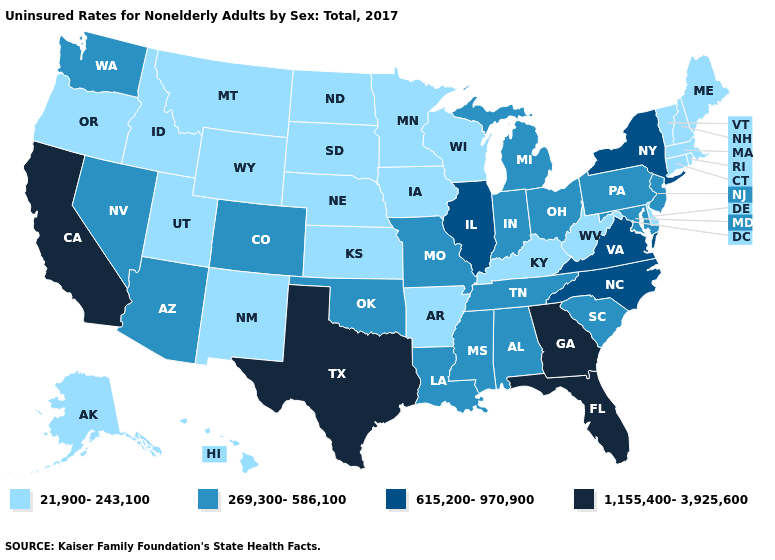Does West Virginia have the same value as Arkansas?
Short answer required. Yes. Does the map have missing data?
Keep it brief. No. Name the states that have a value in the range 269,300-586,100?
Short answer required. Alabama, Arizona, Colorado, Indiana, Louisiana, Maryland, Michigan, Mississippi, Missouri, Nevada, New Jersey, Ohio, Oklahoma, Pennsylvania, South Carolina, Tennessee, Washington. Does Illinois have the highest value in the MidWest?
Be succinct. Yes. Name the states that have a value in the range 615,200-970,900?
Answer briefly. Illinois, New York, North Carolina, Virginia. Does Ohio have a lower value than North Carolina?
Concise answer only. Yes. What is the value of Maine?
Quick response, please. 21,900-243,100. Name the states that have a value in the range 1,155,400-3,925,600?
Quick response, please. California, Florida, Georgia, Texas. Name the states that have a value in the range 269,300-586,100?
Concise answer only. Alabama, Arizona, Colorado, Indiana, Louisiana, Maryland, Michigan, Mississippi, Missouri, Nevada, New Jersey, Ohio, Oklahoma, Pennsylvania, South Carolina, Tennessee, Washington. Name the states that have a value in the range 615,200-970,900?
Write a very short answer. Illinois, New York, North Carolina, Virginia. What is the value of Rhode Island?
Give a very brief answer. 21,900-243,100. Does Illinois have the highest value in the MidWest?
Answer briefly. Yes. Which states hav the highest value in the Northeast?
Answer briefly. New York. Name the states that have a value in the range 1,155,400-3,925,600?
Concise answer only. California, Florida, Georgia, Texas. What is the lowest value in states that border North Carolina?
Give a very brief answer. 269,300-586,100. 